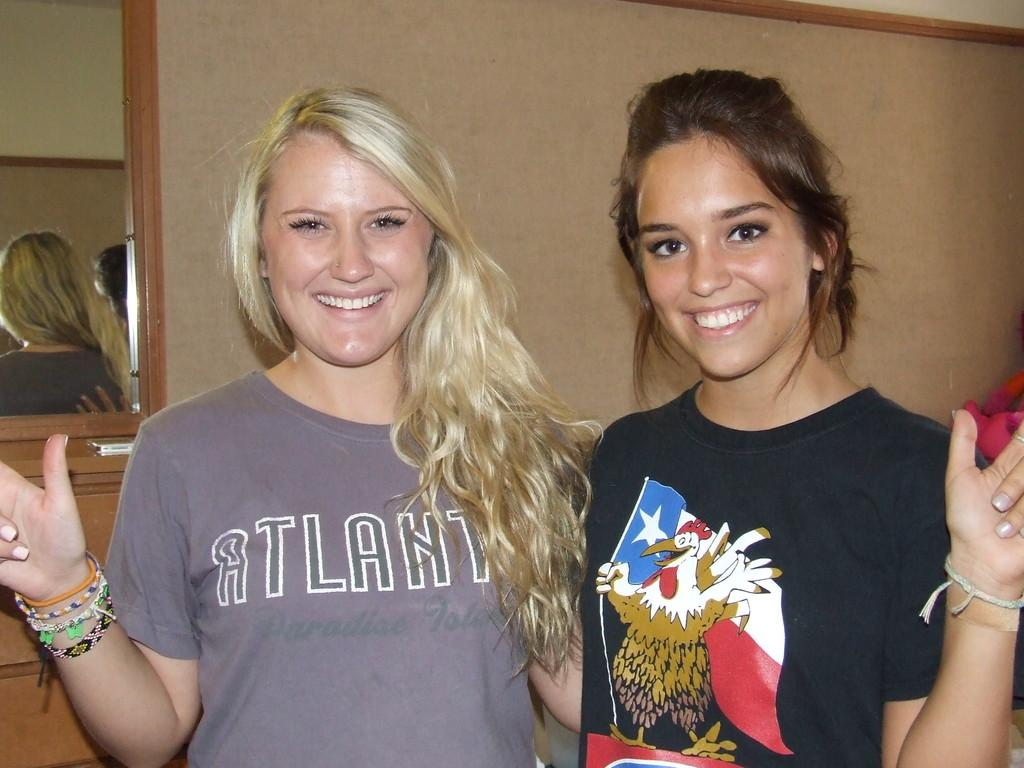How many people are in the image? There are two women in the image. What are the women doing in the image? The women are standing with smiles on their faces. What can be seen behind the women? There is an object behind the women. What is on the wall in the image? There is a mirror on the wall in the image. What month is it in the image? The month cannot be determined from the image, as there is no information provided about the time of year. 